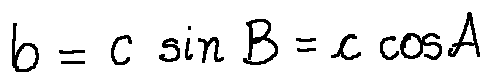Convert formula to latex. <formula><loc_0><loc_0><loc_500><loc_500>b = c \sin B = c \cos A</formula> 